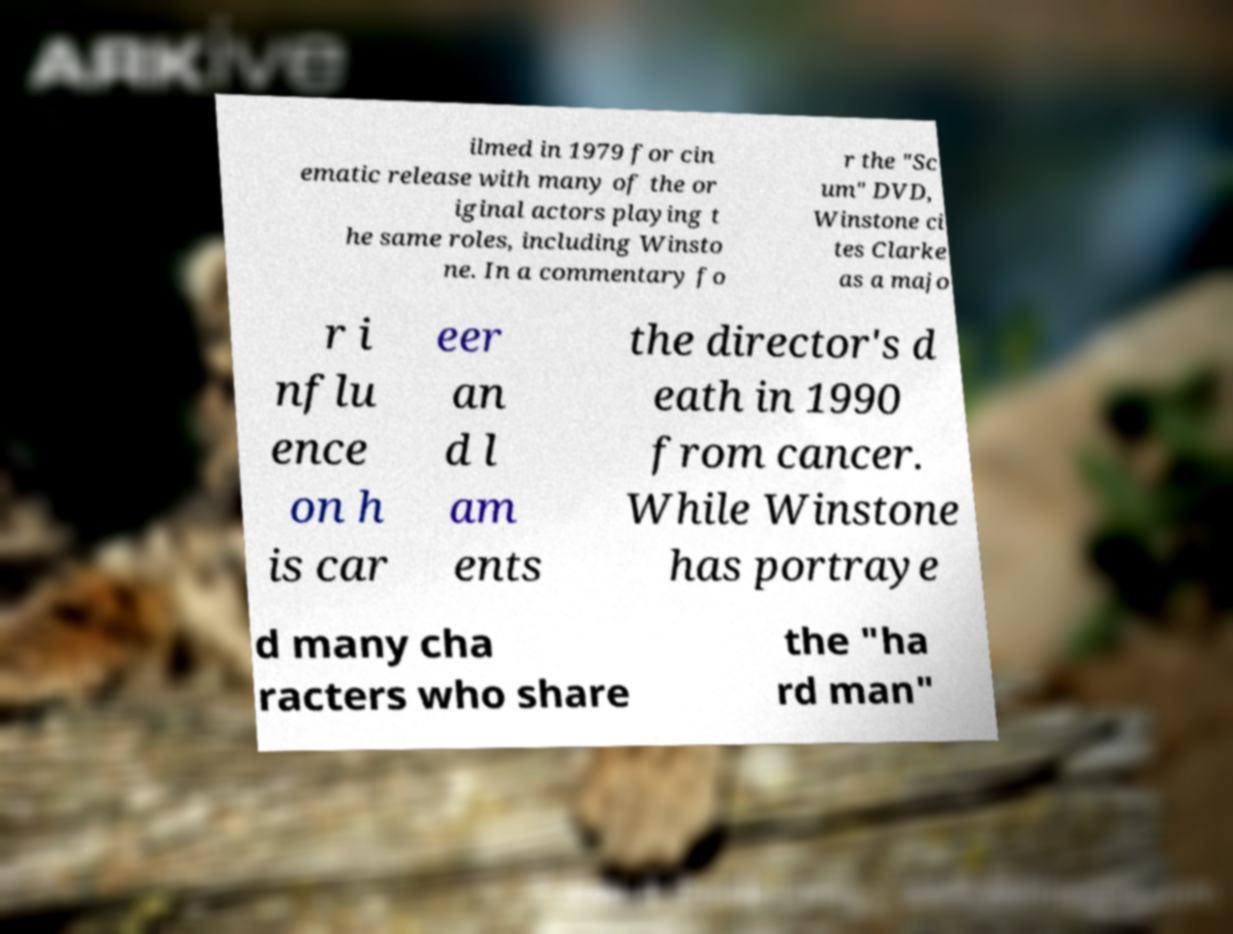Can you read and provide the text displayed in the image?This photo seems to have some interesting text. Can you extract and type it out for me? ilmed in 1979 for cin ematic release with many of the or iginal actors playing t he same roles, including Winsto ne. In a commentary fo r the "Sc um" DVD, Winstone ci tes Clarke as a majo r i nflu ence on h is car eer an d l am ents the director's d eath in 1990 from cancer. While Winstone has portraye d many cha racters who share the "ha rd man" 